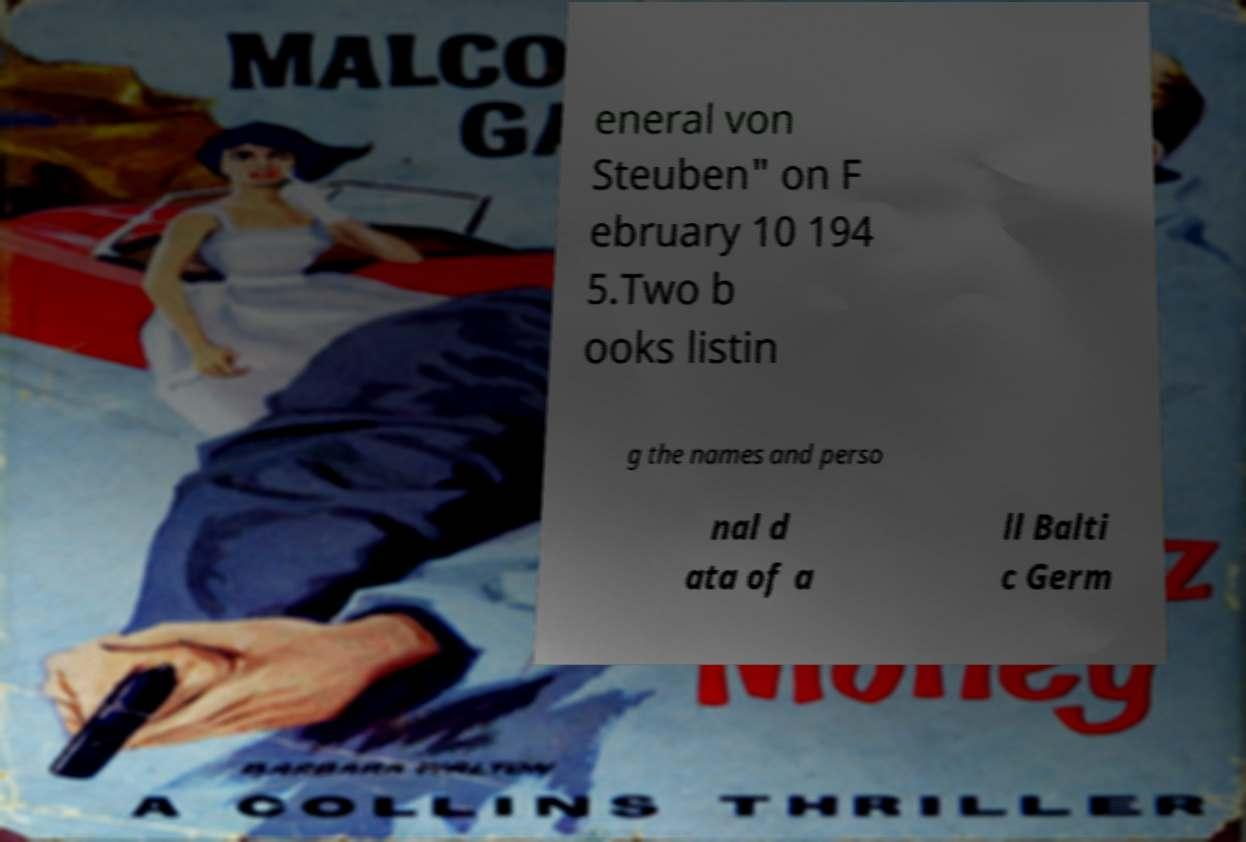Can you read and provide the text displayed in the image?This photo seems to have some interesting text. Can you extract and type it out for me? eneral von Steuben" on F ebruary 10 194 5.Two b ooks listin g the names and perso nal d ata of a ll Balti c Germ 